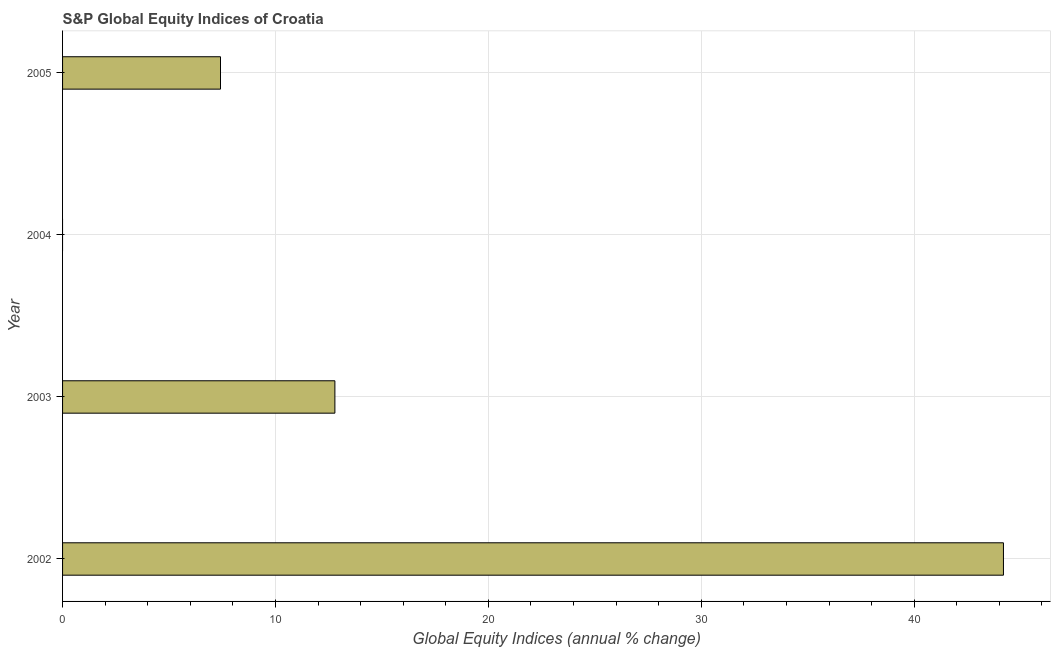Does the graph contain any zero values?
Your answer should be very brief. Yes. What is the title of the graph?
Ensure brevity in your answer.  S&P Global Equity Indices of Croatia. What is the label or title of the X-axis?
Provide a short and direct response. Global Equity Indices (annual % change). What is the label or title of the Y-axis?
Offer a very short reply. Year. What is the s&p global equity indices in 2005?
Your answer should be compact. 7.42. Across all years, what is the maximum s&p global equity indices?
Provide a short and direct response. 44.19. Across all years, what is the minimum s&p global equity indices?
Offer a terse response. 0. In which year was the s&p global equity indices maximum?
Offer a terse response. 2002. What is the sum of the s&p global equity indices?
Offer a very short reply. 64.4. What is the difference between the s&p global equity indices in 2002 and 2005?
Provide a short and direct response. 36.77. What is the average s&p global equity indices per year?
Your answer should be compact. 16.1. What is the median s&p global equity indices?
Your answer should be very brief. 10.1. What is the ratio of the s&p global equity indices in 2002 to that in 2003?
Ensure brevity in your answer.  3.46. Is the difference between the s&p global equity indices in 2002 and 2003 greater than the difference between any two years?
Your answer should be very brief. No. What is the difference between the highest and the second highest s&p global equity indices?
Your answer should be compact. 31.4. Is the sum of the s&p global equity indices in 2002 and 2003 greater than the maximum s&p global equity indices across all years?
Offer a very short reply. Yes. What is the difference between the highest and the lowest s&p global equity indices?
Offer a very short reply. 44.19. In how many years, is the s&p global equity indices greater than the average s&p global equity indices taken over all years?
Make the answer very short. 1. What is the difference between two consecutive major ticks on the X-axis?
Your answer should be compact. 10. What is the Global Equity Indices (annual % change) of 2002?
Offer a terse response. 44.19. What is the Global Equity Indices (annual % change) of 2003?
Provide a short and direct response. 12.79. What is the Global Equity Indices (annual % change) in 2004?
Your answer should be very brief. 0. What is the Global Equity Indices (annual % change) of 2005?
Give a very brief answer. 7.42. What is the difference between the Global Equity Indices (annual % change) in 2002 and 2003?
Provide a short and direct response. 31.4. What is the difference between the Global Equity Indices (annual % change) in 2002 and 2005?
Make the answer very short. 36.77. What is the difference between the Global Equity Indices (annual % change) in 2003 and 2005?
Make the answer very short. 5.37. What is the ratio of the Global Equity Indices (annual % change) in 2002 to that in 2003?
Ensure brevity in your answer.  3.46. What is the ratio of the Global Equity Indices (annual % change) in 2002 to that in 2005?
Offer a very short reply. 5.96. What is the ratio of the Global Equity Indices (annual % change) in 2003 to that in 2005?
Your answer should be very brief. 1.72. 